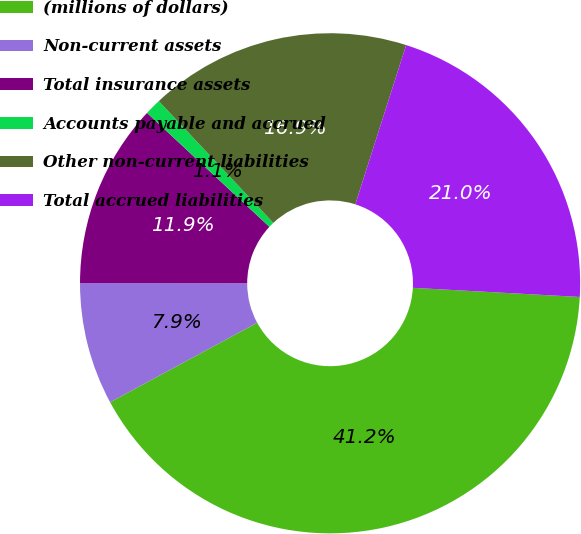Convert chart. <chart><loc_0><loc_0><loc_500><loc_500><pie_chart><fcel>(millions of dollars)<fcel>Non-current assets<fcel>Total insurance assets<fcel>Accounts payable and accrued<fcel>Other non-current liabilities<fcel>Total accrued liabilities<nl><fcel>41.24%<fcel>7.9%<fcel>11.92%<fcel>1.06%<fcel>16.93%<fcel>20.95%<nl></chart> 